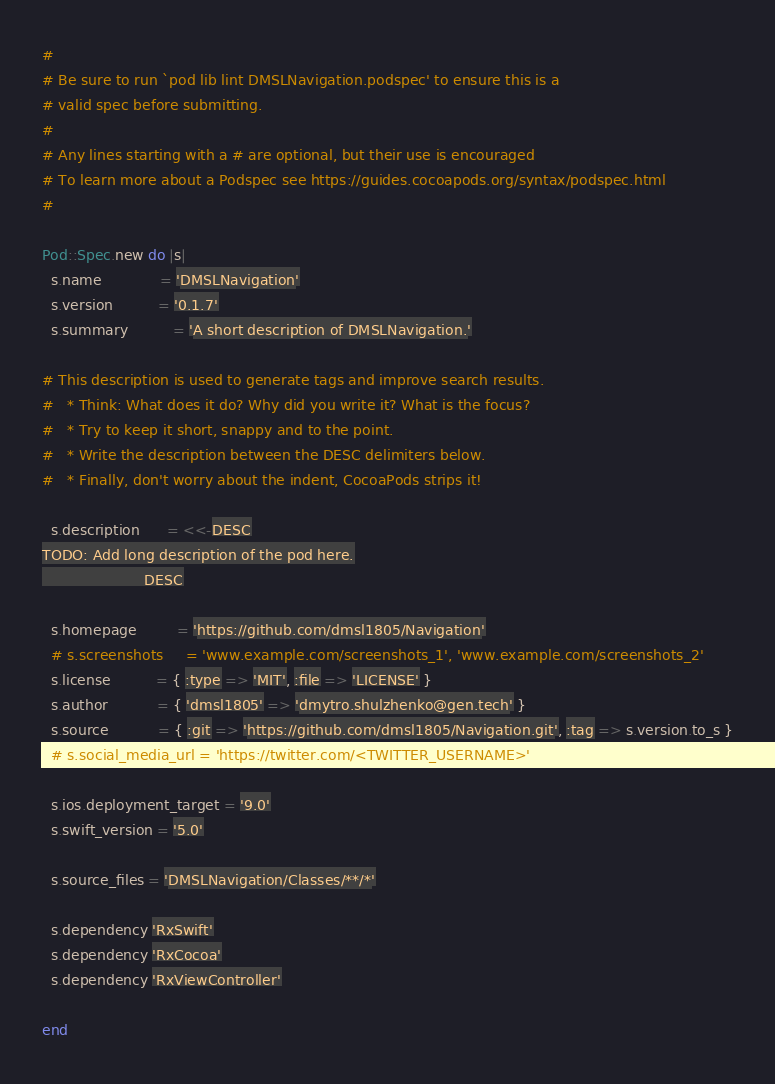Convert code to text. <code><loc_0><loc_0><loc_500><loc_500><_Ruby_>#
# Be sure to run `pod lib lint DMSLNavigation.podspec' to ensure this is a
# valid spec before submitting.
#
# Any lines starting with a # are optional, but their use is encouraged
# To learn more about a Podspec see https://guides.cocoapods.org/syntax/podspec.html
#

Pod::Spec.new do |s|
  s.name             = 'DMSLNavigation'
  s.version          = '0.1.7'
  s.summary          = 'A short description of DMSLNavigation.'

# This description is used to generate tags and improve search results.
#   * Think: What does it do? Why did you write it? What is the focus?
#   * Try to keep it short, snappy and to the point.
#   * Write the description between the DESC delimiters below.
#   * Finally, don't worry about the indent, CocoaPods strips it!

  s.description      = <<-DESC
TODO: Add long description of the pod here.
                       DESC

  s.homepage         = 'https://github.com/dmsl1805/Navigation'
  # s.screenshots     = 'www.example.com/screenshots_1', 'www.example.com/screenshots_2'
  s.license          = { :type => 'MIT', :file => 'LICENSE' }
  s.author           = { 'dmsl1805' => 'dmytro.shulzhenko@gen.tech' }
  s.source           = { :git => 'https://github.com/dmsl1805/Navigation.git', :tag => s.version.to_s }
  # s.social_media_url = 'https://twitter.com/<TWITTER_USERNAME>'

  s.ios.deployment_target = '9.0'
  s.swift_version = '5.0'

  s.source_files = 'DMSLNavigation/Classes/**/*'
 
  s.dependency 'RxSwift'
  s.dependency 'RxCocoa'
  s.dependency 'RxViewController'
  
end
</code> 